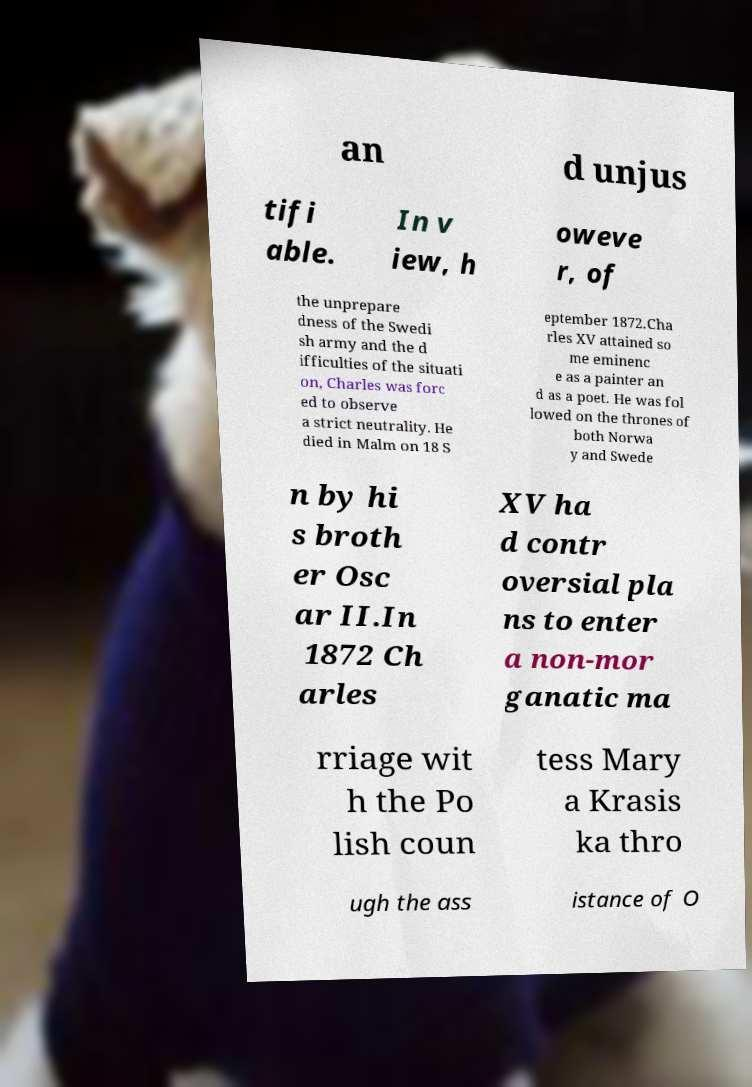Please identify and transcribe the text found in this image. an d unjus tifi able. In v iew, h oweve r, of the unprepare dness of the Swedi sh army and the d ifficulties of the situati on, Charles was forc ed to observe a strict neutrality. He died in Malm on 18 S eptember 1872.Cha rles XV attained so me eminenc e as a painter an d as a poet. He was fol lowed on the thrones of both Norwa y and Swede n by hi s broth er Osc ar II.In 1872 Ch arles XV ha d contr oversial pla ns to enter a non-mor ganatic ma rriage wit h the Po lish coun tess Mary a Krasis ka thro ugh the ass istance of O 